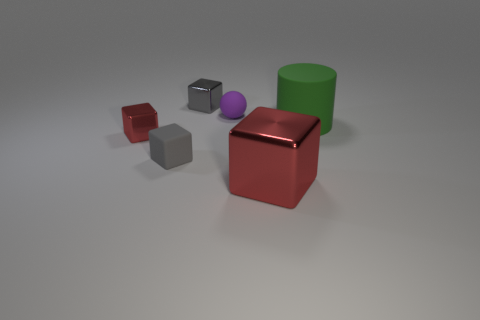Subtract all tiny gray matte blocks. How many blocks are left? 3 Subtract all red cylinders. How many red cubes are left? 2 Subtract all gray cubes. How many cubes are left? 2 Subtract all blocks. How many objects are left? 2 Subtract all brown metallic objects. Subtract all tiny red objects. How many objects are left? 5 Add 2 small rubber spheres. How many small rubber spheres are left? 3 Add 6 balls. How many balls exist? 7 Add 2 tiny purple matte balls. How many objects exist? 8 Subtract 0 brown balls. How many objects are left? 6 Subtract 1 cylinders. How many cylinders are left? 0 